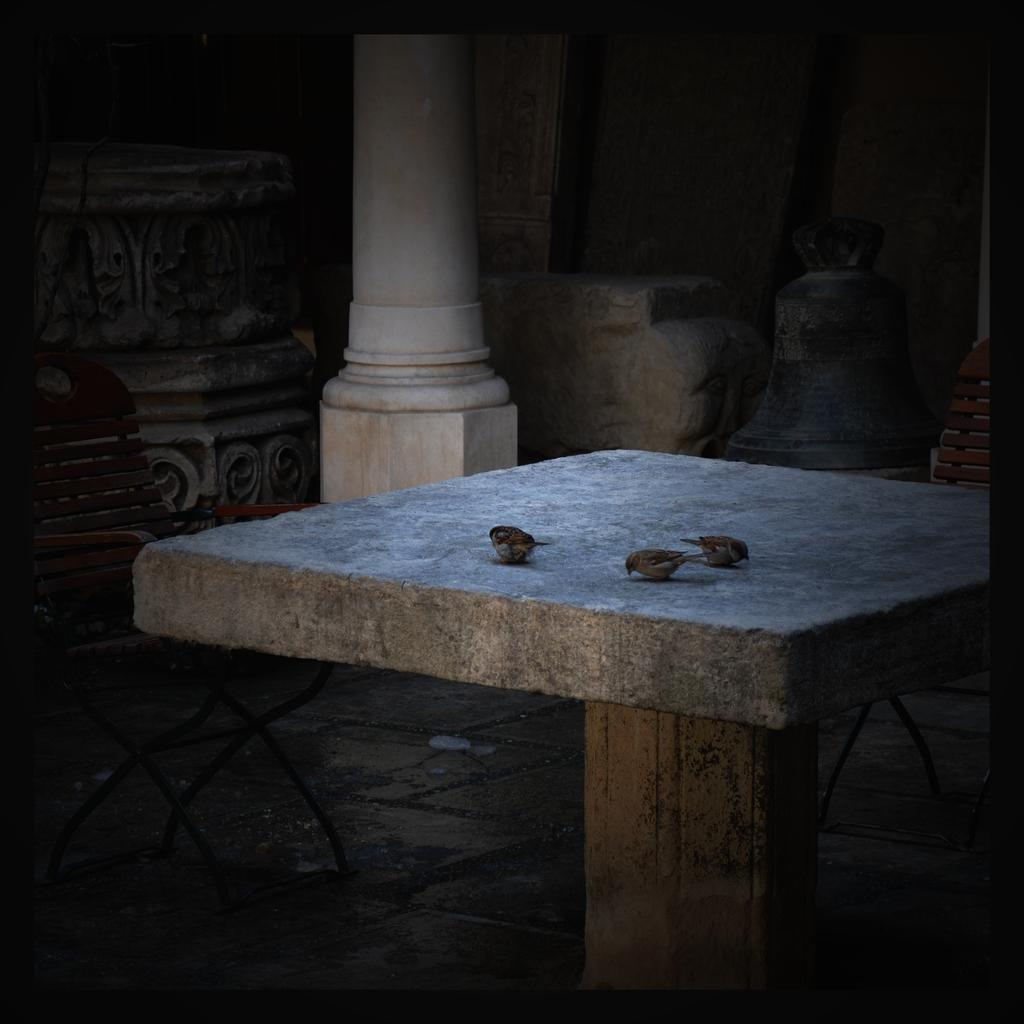What type of table is in the image? There is a square stone table in the image. What is on the table? Three small birds are on the table. What are the birds doing? The birds are eating. What can be seen in the background of the image? There is a white color pillar in the background. Can you describe another prominent feature in the image? There is an old crafted big pillar in the image. What type of polish is being applied to the faucet in the image? There is no faucet present in the image, so it is not possible to determine if any polish is being applied. 